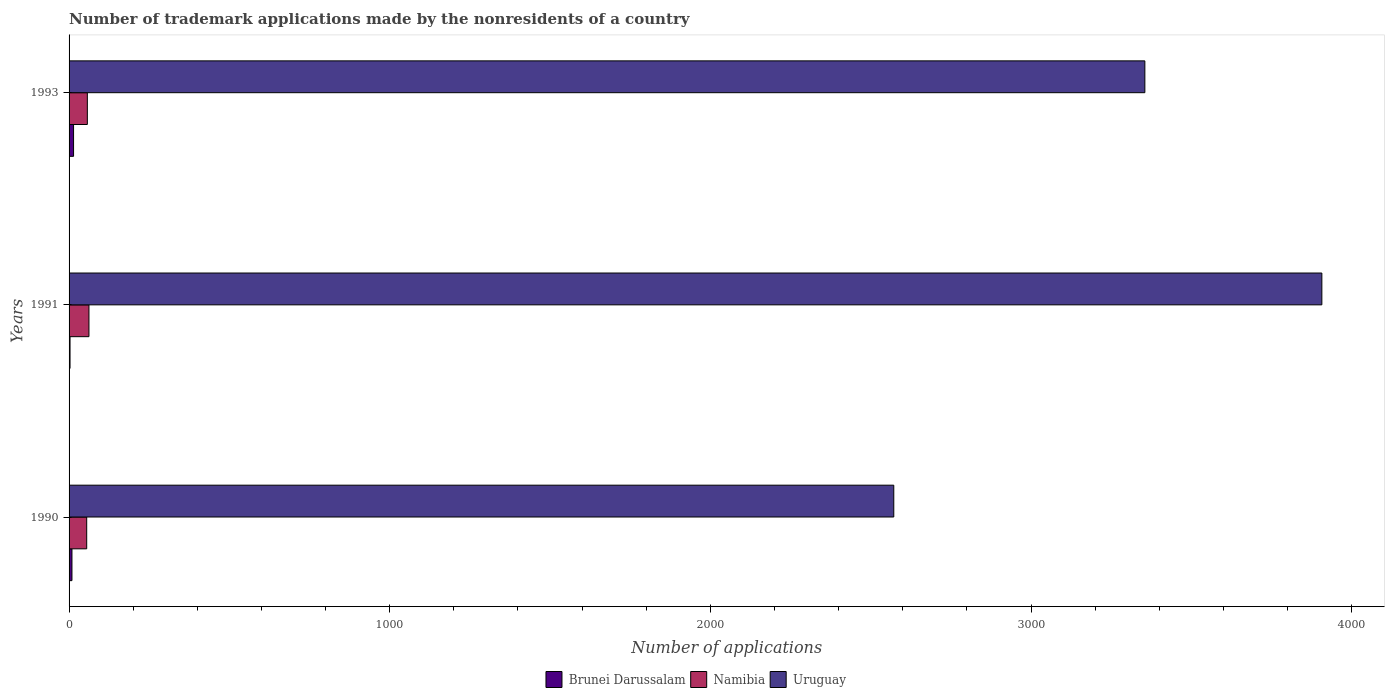How many different coloured bars are there?
Your answer should be very brief. 3. How many groups of bars are there?
Offer a very short reply. 3. Are the number of bars on each tick of the Y-axis equal?
Your response must be concise. Yes. How many bars are there on the 1st tick from the top?
Provide a succinct answer. 3. How many bars are there on the 3rd tick from the bottom?
Make the answer very short. 3. What is the label of the 3rd group of bars from the top?
Your response must be concise. 1990. In how many cases, is the number of bars for a given year not equal to the number of legend labels?
Make the answer very short. 0. What is the number of trademark applications made by the nonresidents in Namibia in 1993?
Offer a very short reply. 57. Across all years, what is the maximum number of trademark applications made by the nonresidents in Uruguay?
Your answer should be very brief. 3907. Across all years, what is the minimum number of trademark applications made by the nonresidents in Namibia?
Ensure brevity in your answer.  55. In which year was the number of trademark applications made by the nonresidents in Uruguay maximum?
Provide a succinct answer. 1991. In which year was the number of trademark applications made by the nonresidents in Namibia minimum?
Your response must be concise. 1990. What is the total number of trademark applications made by the nonresidents in Uruguay in the graph?
Your response must be concise. 9834. What is the difference between the number of trademark applications made by the nonresidents in Uruguay in 1990 and the number of trademark applications made by the nonresidents in Brunei Darussalam in 1993?
Offer a very short reply. 2558. What is the average number of trademark applications made by the nonresidents in Uruguay per year?
Your response must be concise. 3278. In the year 1991, what is the difference between the number of trademark applications made by the nonresidents in Namibia and number of trademark applications made by the nonresidents in Brunei Darussalam?
Offer a very short reply. 59. Is the difference between the number of trademark applications made by the nonresidents in Namibia in 1991 and 1993 greater than the difference between the number of trademark applications made by the nonresidents in Brunei Darussalam in 1991 and 1993?
Give a very brief answer. Yes. What does the 3rd bar from the top in 1990 represents?
Provide a succinct answer. Brunei Darussalam. What does the 1st bar from the bottom in 1991 represents?
Your answer should be compact. Brunei Darussalam. Is it the case that in every year, the sum of the number of trademark applications made by the nonresidents in Namibia and number of trademark applications made by the nonresidents in Uruguay is greater than the number of trademark applications made by the nonresidents in Brunei Darussalam?
Provide a succinct answer. Yes. How many bars are there?
Make the answer very short. 9. Are all the bars in the graph horizontal?
Your answer should be very brief. Yes. Are the values on the major ticks of X-axis written in scientific E-notation?
Your answer should be compact. No. Does the graph contain any zero values?
Provide a short and direct response. No. How many legend labels are there?
Keep it short and to the point. 3. What is the title of the graph?
Offer a very short reply. Number of trademark applications made by the nonresidents of a country. What is the label or title of the X-axis?
Offer a terse response. Number of applications. What is the Number of applications of Namibia in 1990?
Ensure brevity in your answer.  55. What is the Number of applications in Uruguay in 1990?
Provide a short and direct response. 2572. What is the Number of applications in Brunei Darussalam in 1991?
Your response must be concise. 3. What is the Number of applications of Uruguay in 1991?
Your answer should be very brief. 3907. What is the Number of applications of Brunei Darussalam in 1993?
Offer a terse response. 14. What is the Number of applications of Namibia in 1993?
Keep it short and to the point. 57. What is the Number of applications of Uruguay in 1993?
Your answer should be very brief. 3355. Across all years, what is the maximum Number of applications of Namibia?
Ensure brevity in your answer.  62. Across all years, what is the maximum Number of applications in Uruguay?
Provide a succinct answer. 3907. Across all years, what is the minimum Number of applications of Brunei Darussalam?
Give a very brief answer. 3. Across all years, what is the minimum Number of applications in Uruguay?
Provide a succinct answer. 2572. What is the total Number of applications in Namibia in the graph?
Your response must be concise. 174. What is the total Number of applications in Uruguay in the graph?
Your answer should be compact. 9834. What is the difference between the Number of applications of Uruguay in 1990 and that in 1991?
Offer a terse response. -1335. What is the difference between the Number of applications of Uruguay in 1990 and that in 1993?
Offer a very short reply. -783. What is the difference between the Number of applications in Brunei Darussalam in 1991 and that in 1993?
Make the answer very short. -11. What is the difference between the Number of applications of Namibia in 1991 and that in 1993?
Provide a short and direct response. 5. What is the difference between the Number of applications in Uruguay in 1991 and that in 1993?
Offer a very short reply. 552. What is the difference between the Number of applications in Brunei Darussalam in 1990 and the Number of applications in Namibia in 1991?
Provide a short and direct response. -53. What is the difference between the Number of applications of Brunei Darussalam in 1990 and the Number of applications of Uruguay in 1991?
Provide a short and direct response. -3898. What is the difference between the Number of applications in Namibia in 1990 and the Number of applications in Uruguay in 1991?
Provide a succinct answer. -3852. What is the difference between the Number of applications in Brunei Darussalam in 1990 and the Number of applications in Namibia in 1993?
Offer a terse response. -48. What is the difference between the Number of applications of Brunei Darussalam in 1990 and the Number of applications of Uruguay in 1993?
Keep it short and to the point. -3346. What is the difference between the Number of applications in Namibia in 1990 and the Number of applications in Uruguay in 1993?
Give a very brief answer. -3300. What is the difference between the Number of applications of Brunei Darussalam in 1991 and the Number of applications of Namibia in 1993?
Your answer should be very brief. -54. What is the difference between the Number of applications in Brunei Darussalam in 1991 and the Number of applications in Uruguay in 1993?
Make the answer very short. -3352. What is the difference between the Number of applications in Namibia in 1991 and the Number of applications in Uruguay in 1993?
Keep it short and to the point. -3293. What is the average Number of applications of Brunei Darussalam per year?
Your answer should be very brief. 8.67. What is the average Number of applications of Uruguay per year?
Offer a terse response. 3278. In the year 1990, what is the difference between the Number of applications in Brunei Darussalam and Number of applications in Namibia?
Provide a short and direct response. -46. In the year 1990, what is the difference between the Number of applications of Brunei Darussalam and Number of applications of Uruguay?
Give a very brief answer. -2563. In the year 1990, what is the difference between the Number of applications of Namibia and Number of applications of Uruguay?
Provide a short and direct response. -2517. In the year 1991, what is the difference between the Number of applications in Brunei Darussalam and Number of applications in Namibia?
Your response must be concise. -59. In the year 1991, what is the difference between the Number of applications in Brunei Darussalam and Number of applications in Uruguay?
Make the answer very short. -3904. In the year 1991, what is the difference between the Number of applications in Namibia and Number of applications in Uruguay?
Your answer should be very brief. -3845. In the year 1993, what is the difference between the Number of applications of Brunei Darussalam and Number of applications of Namibia?
Offer a terse response. -43. In the year 1993, what is the difference between the Number of applications in Brunei Darussalam and Number of applications in Uruguay?
Offer a very short reply. -3341. In the year 1993, what is the difference between the Number of applications in Namibia and Number of applications in Uruguay?
Ensure brevity in your answer.  -3298. What is the ratio of the Number of applications of Namibia in 1990 to that in 1991?
Provide a short and direct response. 0.89. What is the ratio of the Number of applications in Uruguay in 1990 to that in 1991?
Provide a succinct answer. 0.66. What is the ratio of the Number of applications of Brunei Darussalam in 1990 to that in 1993?
Make the answer very short. 0.64. What is the ratio of the Number of applications in Namibia in 1990 to that in 1993?
Provide a short and direct response. 0.96. What is the ratio of the Number of applications in Uruguay in 1990 to that in 1993?
Your response must be concise. 0.77. What is the ratio of the Number of applications in Brunei Darussalam in 1991 to that in 1993?
Your answer should be very brief. 0.21. What is the ratio of the Number of applications of Namibia in 1991 to that in 1993?
Give a very brief answer. 1.09. What is the ratio of the Number of applications in Uruguay in 1991 to that in 1993?
Provide a succinct answer. 1.16. What is the difference between the highest and the second highest Number of applications in Namibia?
Your response must be concise. 5. What is the difference between the highest and the second highest Number of applications in Uruguay?
Make the answer very short. 552. What is the difference between the highest and the lowest Number of applications of Namibia?
Give a very brief answer. 7. What is the difference between the highest and the lowest Number of applications of Uruguay?
Give a very brief answer. 1335. 